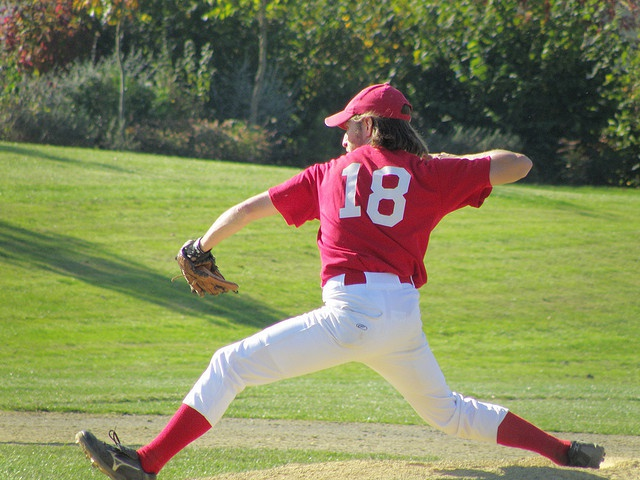Describe the objects in this image and their specific colors. I can see people in olive, brown, darkgray, and maroon tones and baseball glove in olive, gray, and brown tones in this image. 